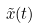<formula> <loc_0><loc_0><loc_500><loc_500>\tilde { x } ( t )</formula> 